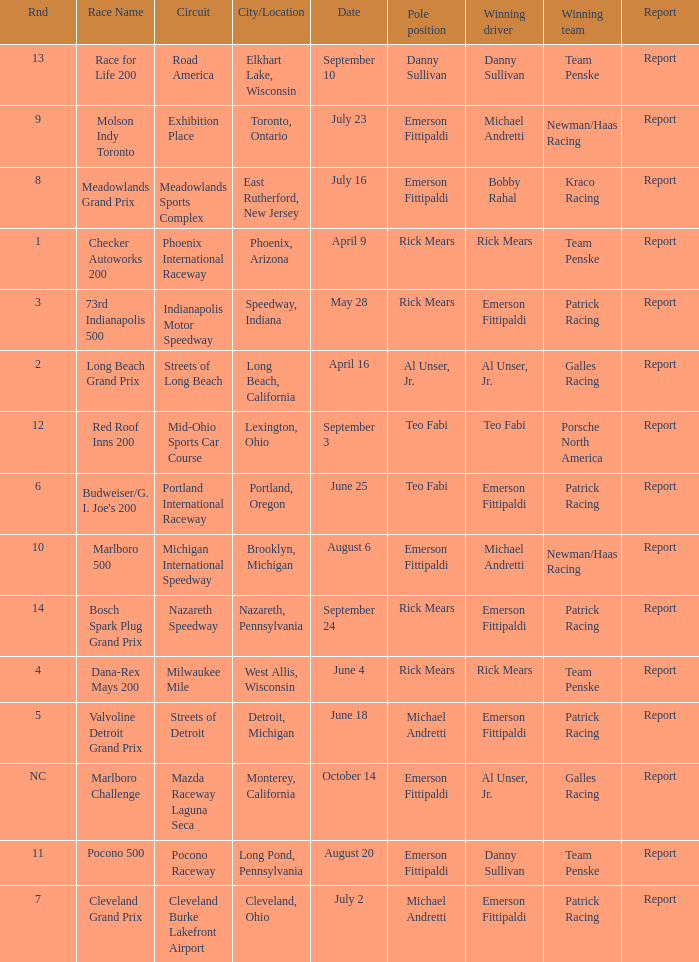How many reports were the for the cleveland burke lakefront airport circut? 1.0. 